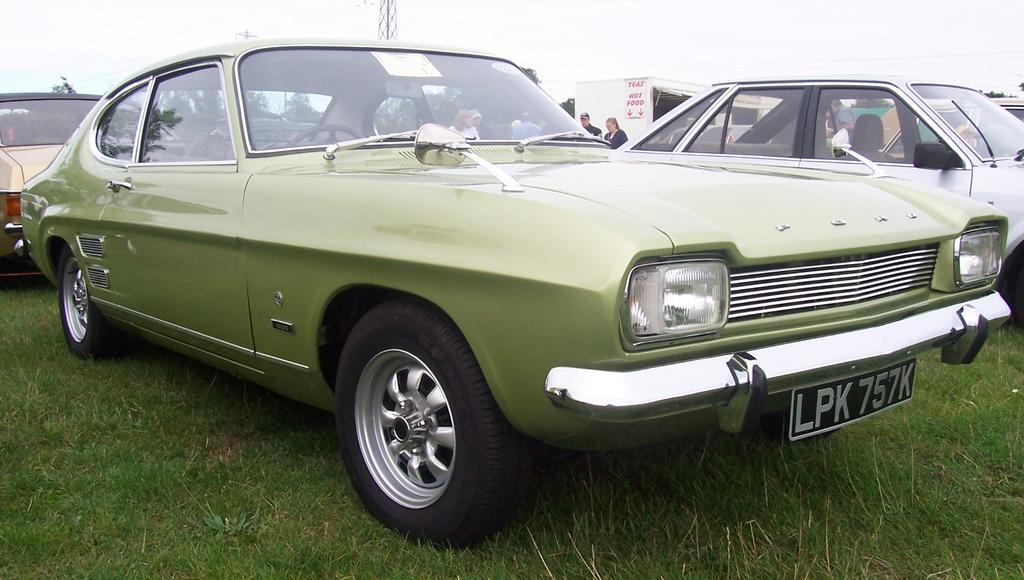Can you describe this image briefly? In this image I can see few vehicles. In front the vehicle is in green color. In the background I can see few people standing, trees in green color, the tower and the sky is in white color. 